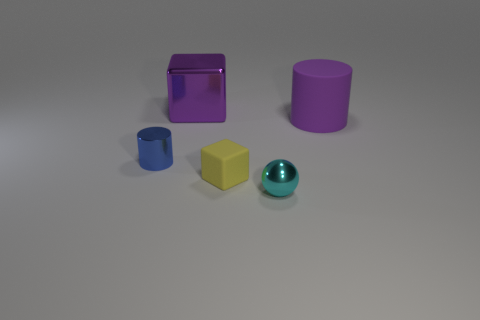Add 5 big red things. How many objects exist? 10 Subtract all balls. How many objects are left? 4 Add 1 big purple metal things. How many big purple metal things exist? 2 Subtract 0 green blocks. How many objects are left? 5 Subtract all brown rubber cylinders. Subtract all big purple metallic cubes. How many objects are left? 4 Add 3 tiny balls. How many tiny balls are left? 4 